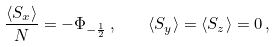<formula> <loc_0><loc_0><loc_500><loc_500>\frac { \langle S _ { x } \rangle } { N } = - \Phi _ { - \frac { 1 } { 2 } } \, , \quad \langle S _ { y } \rangle = { \langle S _ { z } \rangle } = 0 \, ,</formula> 